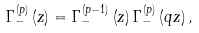<formula> <loc_0><loc_0><loc_500><loc_500>\Gamma _ { - } ^ { \left ( p \right ) } \left ( z \right ) = \Gamma _ { - } ^ { \left ( p - 1 \right ) } \left ( z \right ) \Gamma _ { - } ^ { \left ( p \right ) } \left ( q z \right ) ,</formula> 